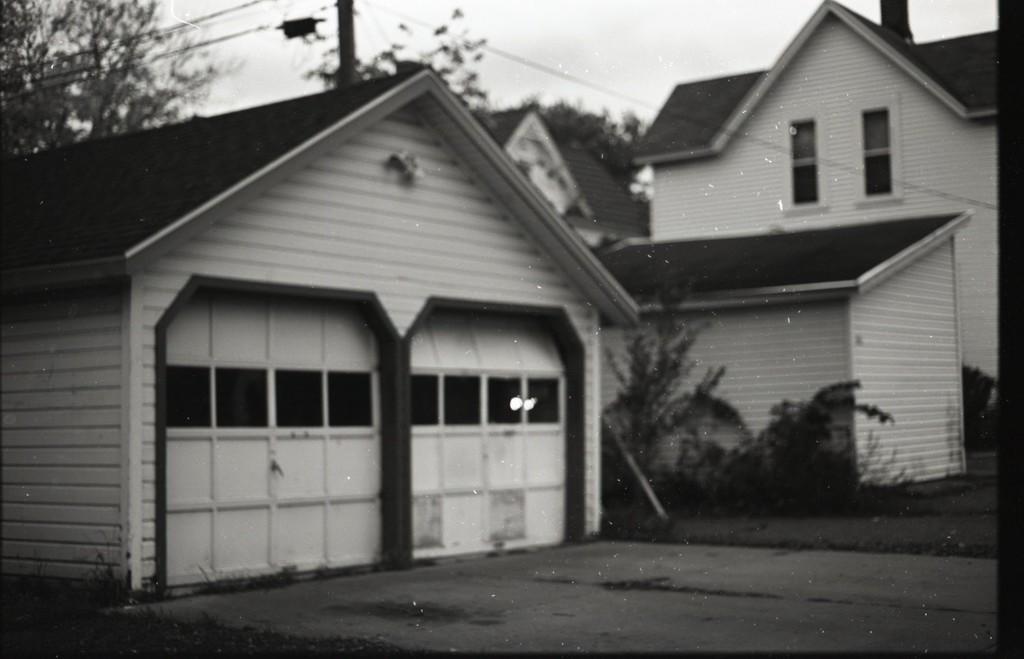How would you summarize this image in a sentence or two? In this image I can see a building. Background I can see few trees, and sky in white color 